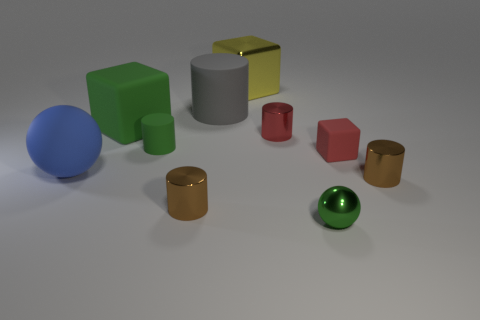Subtract all small red metal cylinders. How many cylinders are left? 4 Subtract all yellow cubes. How many cubes are left? 2 Subtract all cubes. How many objects are left? 7 Subtract all gray spheres. How many red cylinders are left? 1 Add 6 gray matte objects. How many gray matte objects are left? 7 Add 4 green rubber cubes. How many green rubber cubes exist? 5 Subtract 1 red cylinders. How many objects are left? 9 Subtract 1 spheres. How many spheres are left? 1 Subtract all red cylinders. Subtract all red spheres. How many cylinders are left? 4 Subtract all big gray matte cylinders. Subtract all tiny things. How many objects are left? 3 